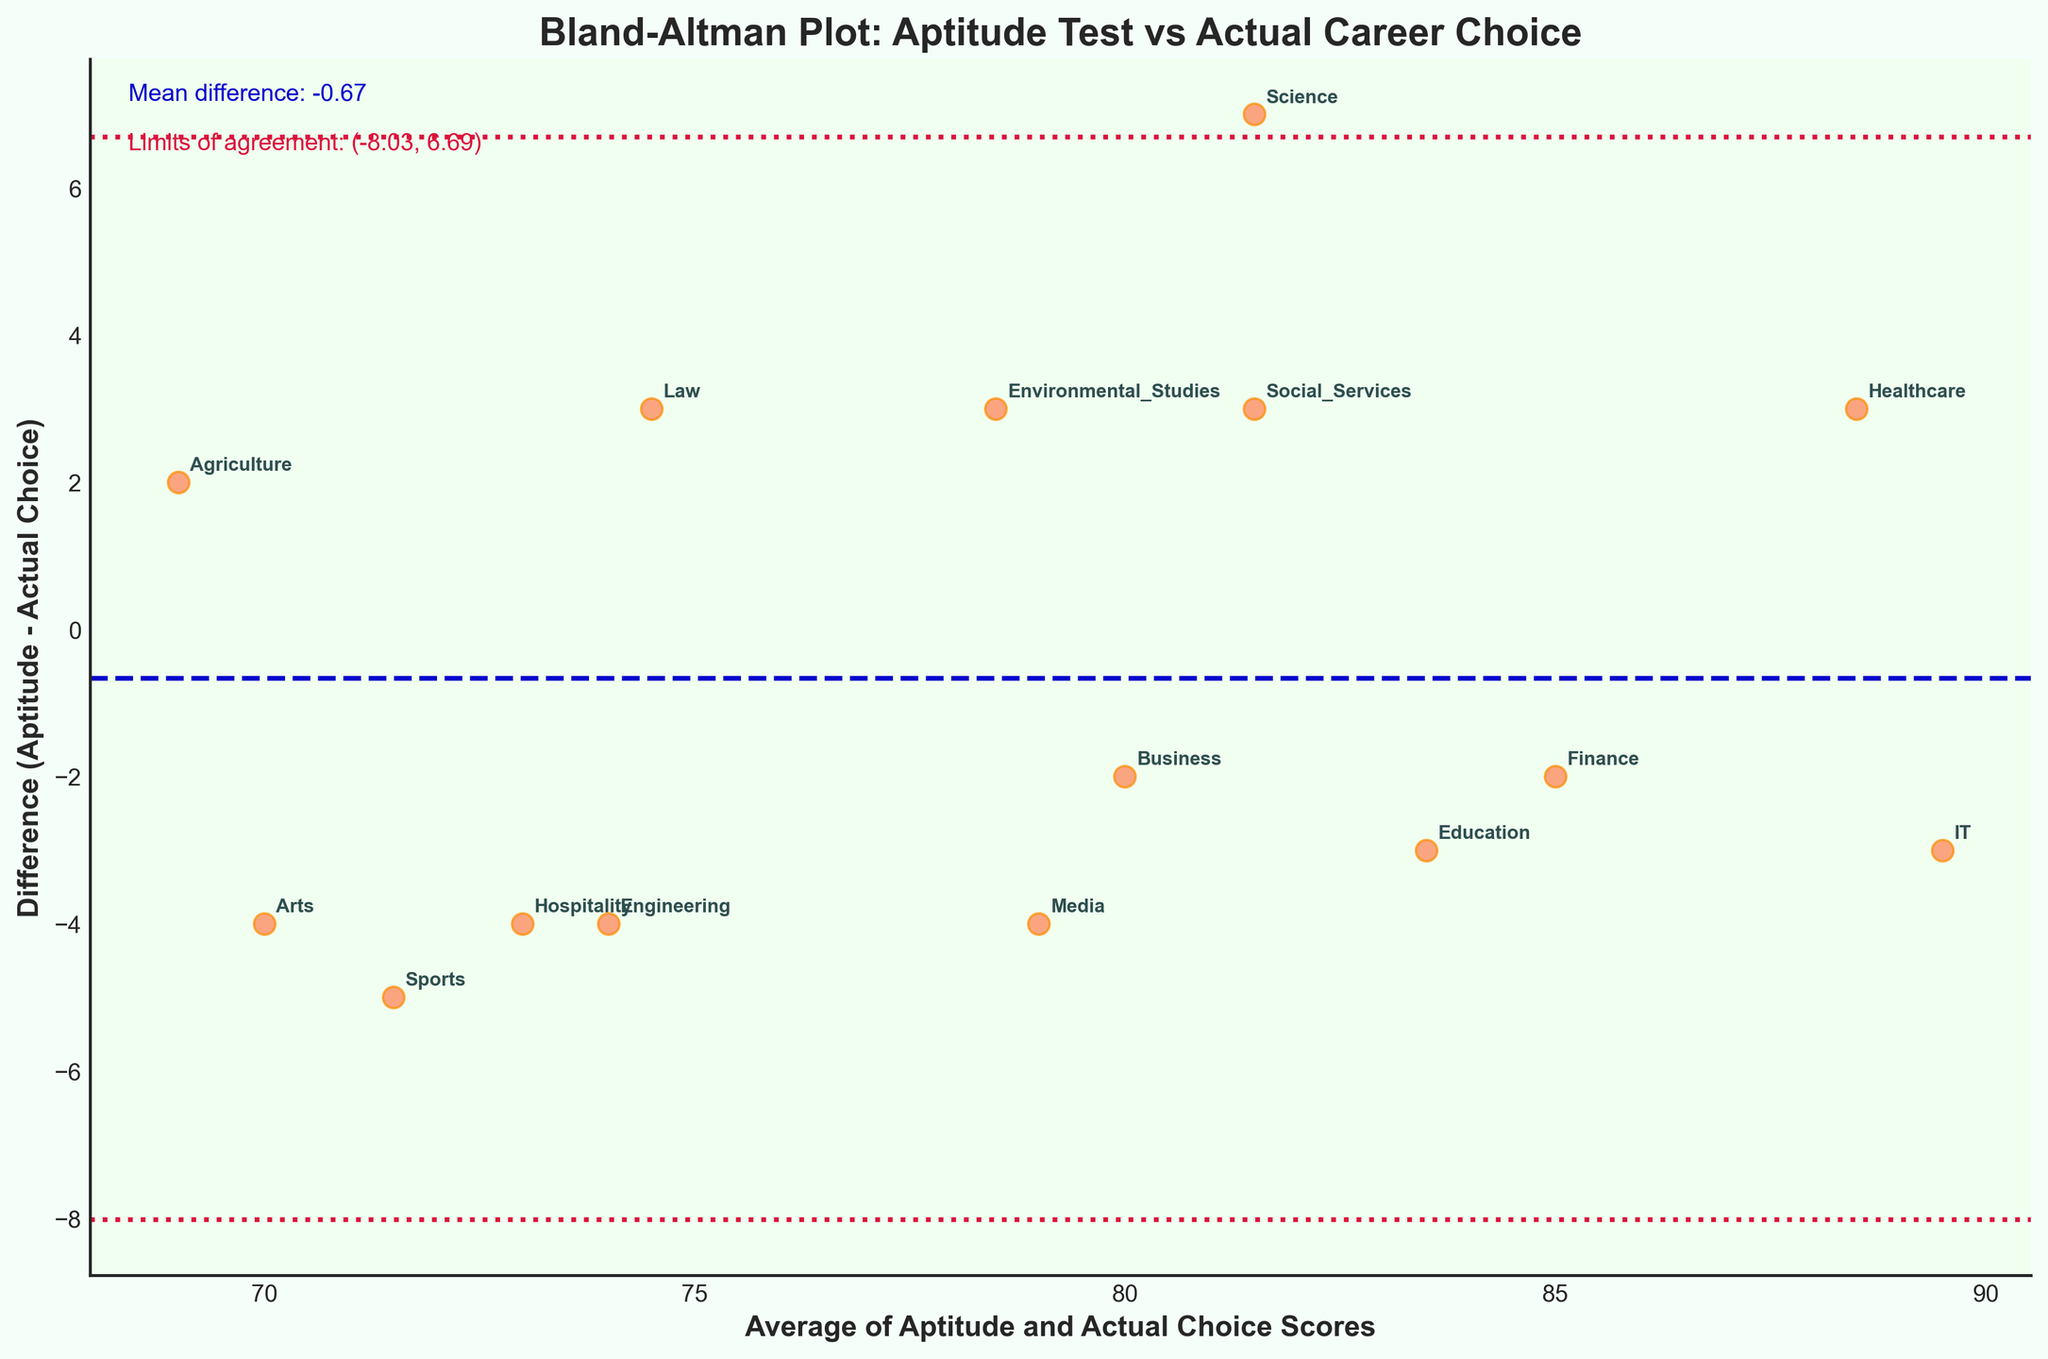How many career fields are represented in the plot? Count the number of unique career fields labeled on the plot.
Answer: 15 What is the overall mean difference between aptitude and actual choice scores? Read the value of the mean difference line, which is explicitly annotated in the plot.
Answer: Approximately 0.40 Which career field has the highest average score? Locate the highest point on the x-axis and read the corresponding career field from the annotation.
Answer: IT Which career field has the largest difference between aptitude and actual choice scores? Find the largest vertical distance between a data point and the x-axis (difference of 7), then read the corresponding career field from the annotation.
Answer: Science What are the limits of agreement in the plot? Read the two horizontal lines labeled as limits of agreement on the plot.
Answer: Approximately -4.55 and 5.35 Is the overall agreement between aptitude scores and actual career choices positive or negative? The mean difference is slightly above the x-axis, indicating aptitude scores are generally higher than actual choice scores.
Answer: Positive What color represents the data points in the plot? Observe the color of the scattered points.
Answer: Coral Which two career fields have very similar average scores but different differences? Notice career fields placed closely on the x-axis (around average of 81.5) with different heights on the y-axis.
Answer: Science and Social Services Are there any career fields where the aptitude scores and actual choice scores match exactly? Look for a data point where the difference (y-axis value) is 0.
Answer: None 